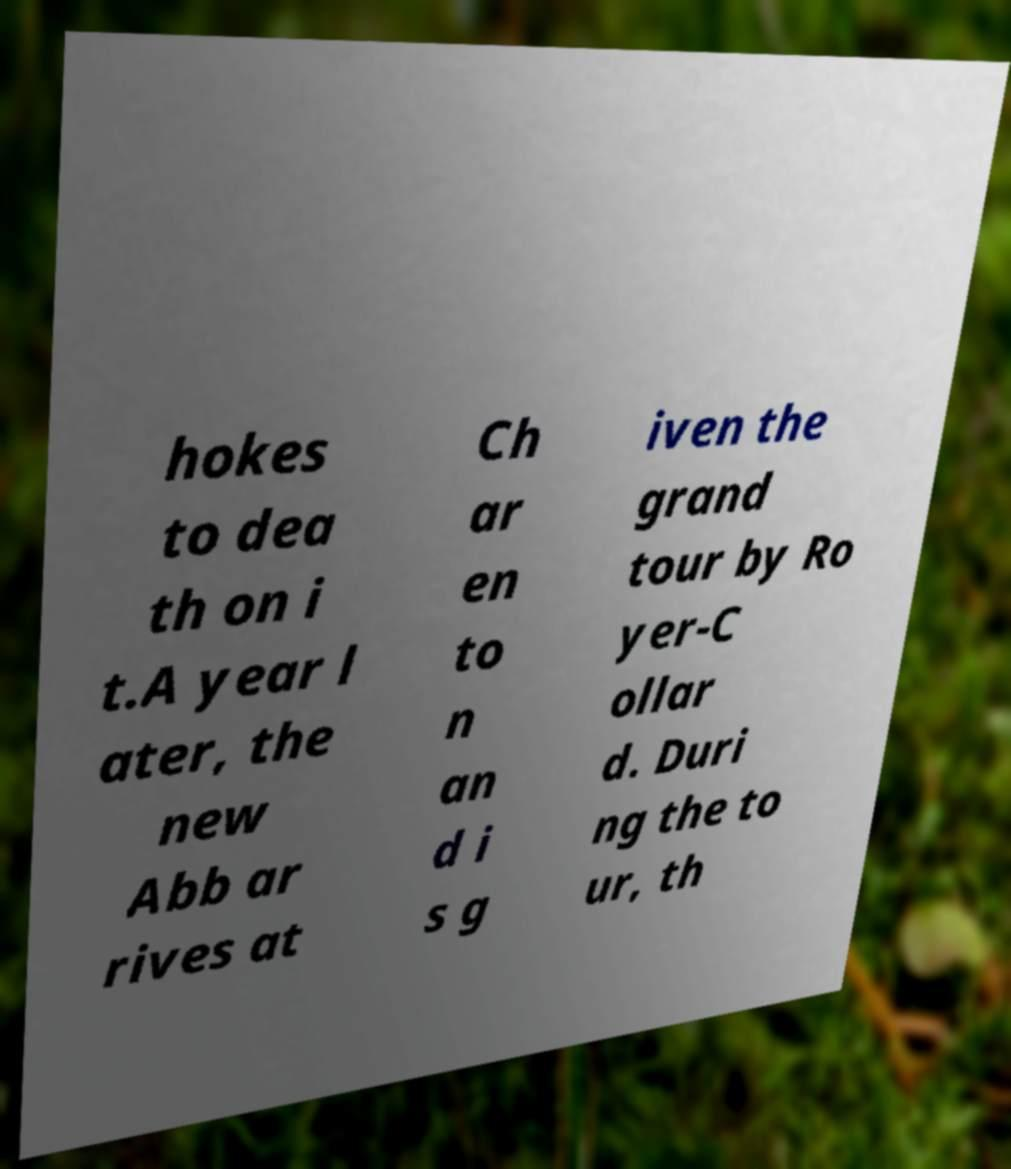Could you assist in decoding the text presented in this image and type it out clearly? hokes to dea th on i t.A year l ater, the new Abb ar rives at Ch ar en to n an d i s g iven the grand tour by Ro yer-C ollar d. Duri ng the to ur, th 